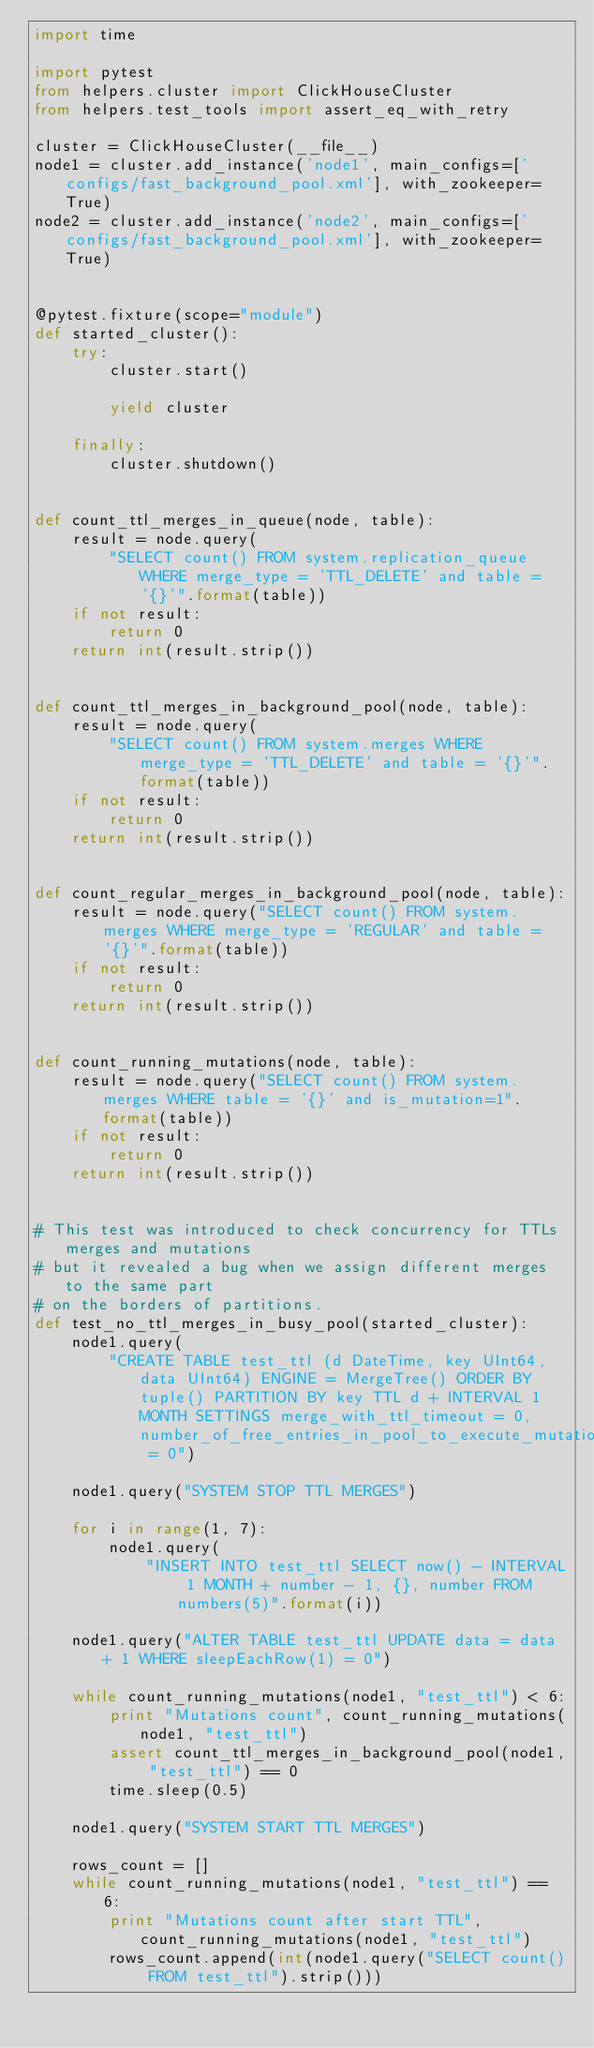Convert code to text. <code><loc_0><loc_0><loc_500><loc_500><_Python_>import time

import pytest
from helpers.cluster import ClickHouseCluster
from helpers.test_tools import assert_eq_with_retry

cluster = ClickHouseCluster(__file__)
node1 = cluster.add_instance('node1', main_configs=['configs/fast_background_pool.xml'], with_zookeeper=True)
node2 = cluster.add_instance('node2', main_configs=['configs/fast_background_pool.xml'], with_zookeeper=True)


@pytest.fixture(scope="module")
def started_cluster():
    try:
        cluster.start()

        yield cluster

    finally:
        cluster.shutdown()


def count_ttl_merges_in_queue(node, table):
    result = node.query(
        "SELECT count() FROM system.replication_queue WHERE merge_type = 'TTL_DELETE' and table = '{}'".format(table))
    if not result:
        return 0
    return int(result.strip())


def count_ttl_merges_in_background_pool(node, table):
    result = node.query(
        "SELECT count() FROM system.merges WHERE merge_type = 'TTL_DELETE' and table = '{}'".format(table))
    if not result:
        return 0
    return int(result.strip())


def count_regular_merges_in_background_pool(node, table):
    result = node.query("SELECT count() FROM system.merges WHERE merge_type = 'REGULAR' and table = '{}'".format(table))
    if not result:
        return 0
    return int(result.strip())


def count_running_mutations(node, table):
    result = node.query("SELECT count() FROM system.merges WHERE table = '{}' and is_mutation=1".format(table))
    if not result:
        return 0
    return int(result.strip())


# This test was introduced to check concurrency for TTLs merges and mutations
# but it revealed a bug when we assign different merges to the same part
# on the borders of partitions.
def test_no_ttl_merges_in_busy_pool(started_cluster):
    node1.query(
        "CREATE TABLE test_ttl (d DateTime, key UInt64, data UInt64) ENGINE = MergeTree() ORDER BY tuple() PARTITION BY key TTL d + INTERVAL 1 MONTH SETTINGS merge_with_ttl_timeout = 0, number_of_free_entries_in_pool_to_execute_mutation = 0")

    node1.query("SYSTEM STOP TTL MERGES")

    for i in range(1, 7):
        node1.query(
            "INSERT INTO test_ttl SELECT now() - INTERVAL 1 MONTH + number - 1, {}, number FROM numbers(5)".format(i))

    node1.query("ALTER TABLE test_ttl UPDATE data = data + 1 WHERE sleepEachRow(1) = 0")

    while count_running_mutations(node1, "test_ttl") < 6:
        print "Mutations count", count_running_mutations(node1, "test_ttl")
        assert count_ttl_merges_in_background_pool(node1, "test_ttl") == 0
        time.sleep(0.5)

    node1.query("SYSTEM START TTL MERGES")

    rows_count = []
    while count_running_mutations(node1, "test_ttl") == 6:
        print "Mutations count after start TTL", count_running_mutations(node1, "test_ttl")
        rows_count.append(int(node1.query("SELECT count() FROM test_ttl").strip()))</code> 